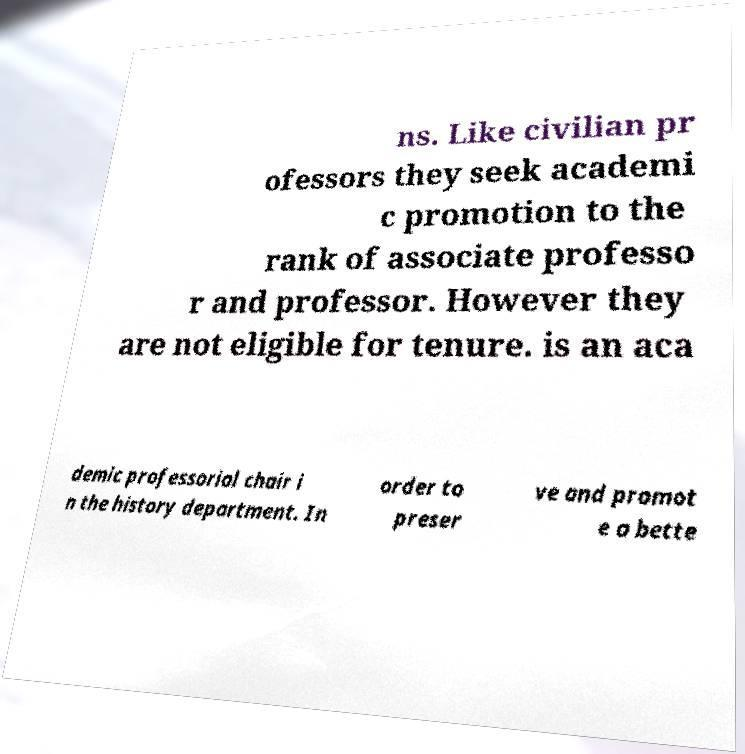Could you assist in decoding the text presented in this image and type it out clearly? ns. Like civilian pr ofessors they seek academi c promotion to the rank of associate professo r and professor. However they are not eligible for tenure. is an aca demic professorial chair i n the history department. In order to preser ve and promot e a bette 